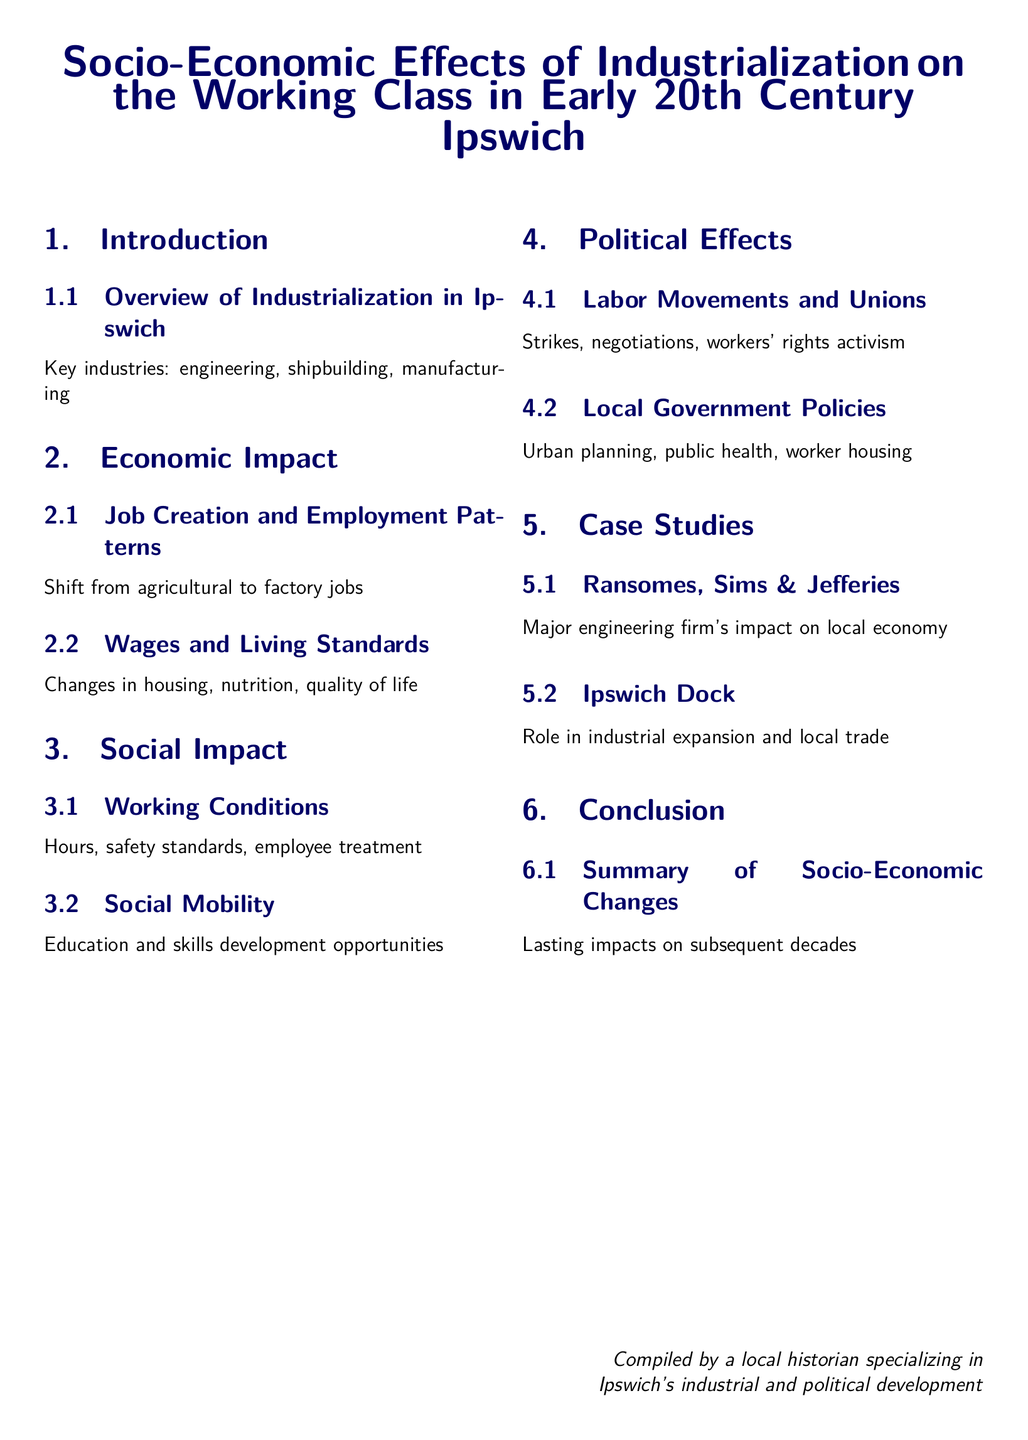What are the key industries in Ipswich? The section titled "Overview of Industrialization in Ipswich" lists the main industries contributing to industrialization in the area.
Answer: engineering, shipbuilding, manufacturing What is the shift in employment patterns? The section "Job Creation and Employment Patterns" discusses the transition occurring in the workforce.
Answer: from agricultural to factory jobs What aspect of living standards changed due to industrialization? The "Wages and Living Standards" subsection outlines various elements of quality of life affected by industrial changes.
Answer: housing What were the main safety considerations for workers? The "Working Conditions" subsection provides insights into the crucial aspects of employee safety.
Answer: safety standards What type of activism is mentioned in relation to labor? Within the "Labor Movements and Unions" subsection, various forms of activism concerning labor are addressed.
Answer: workers' rights activism What company is highlighted in the case studies? The document lists specific examples of major local firms to showcase their impact.
Answer: Ransomes, Sims & Jefferies What role did the Ipswich Dock play in industrial expansion? The subsection "Ipswich Dock" explains its significance in terms of trade and expansion.
Answer: local trade What is the conclusion about the changes experienced? The "Summary of Socio-Economic Changes" reflects on the overall consequences of industrialization on future developments.
Answer: Lasting impacts on subsequent decades 